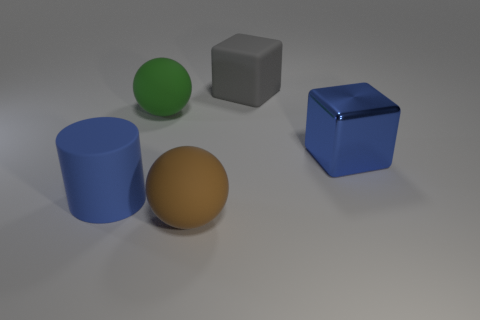Add 4 green matte things. How many objects exist? 9 Subtract all balls. How many objects are left? 3 Add 3 large red rubber spheres. How many large red rubber spheres exist? 3 Subtract 1 green balls. How many objects are left? 4 Subtract all green metal things. Subtract all large matte spheres. How many objects are left? 3 Add 1 blue rubber objects. How many blue rubber objects are left? 2 